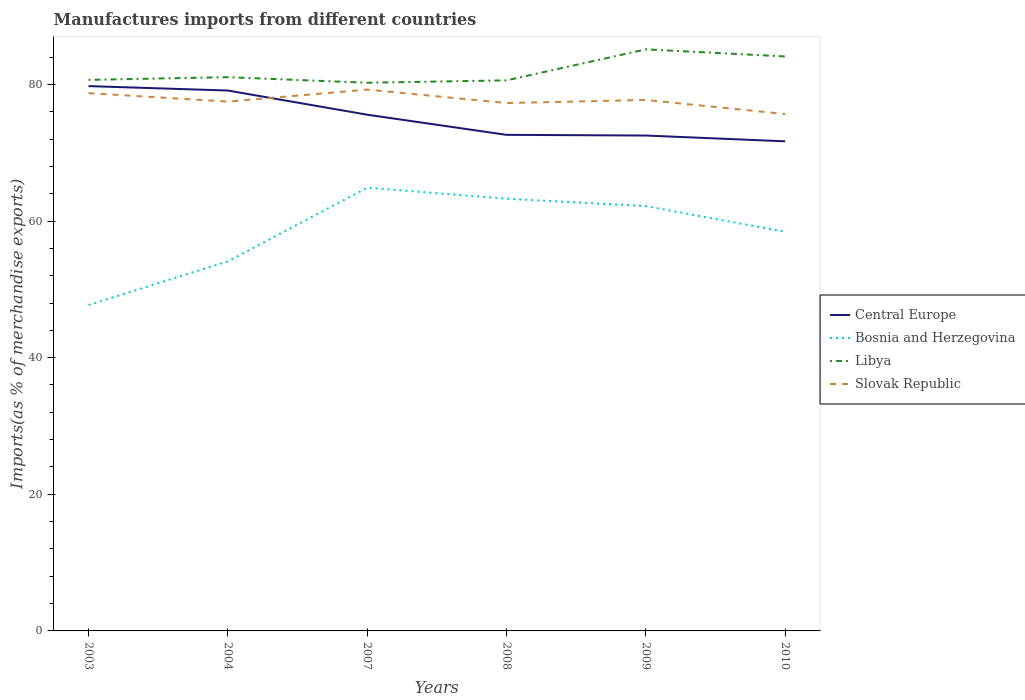How many different coloured lines are there?
Give a very brief answer. 4. Is the number of lines equal to the number of legend labels?
Offer a very short reply. Yes. Across all years, what is the maximum percentage of imports to different countries in Libya?
Your answer should be very brief. 80.24. What is the total percentage of imports to different countries in Central Europe in the graph?
Offer a very short reply. 8.08. What is the difference between the highest and the second highest percentage of imports to different countries in Libya?
Your answer should be compact. 4.89. What is the difference between the highest and the lowest percentage of imports to different countries in Central Europe?
Make the answer very short. 3. How many years are there in the graph?
Your response must be concise. 6. Does the graph contain grids?
Your answer should be compact. No. What is the title of the graph?
Keep it short and to the point. Manufactures imports from different countries. What is the label or title of the Y-axis?
Your answer should be compact. Imports(as % of merchandise exports). What is the Imports(as % of merchandise exports) in Central Europe in 2003?
Your answer should be compact. 79.75. What is the Imports(as % of merchandise exports) in Bosnia and Herzegovina in 2003?
Offer a very short reply. 47.71. What is the Imports(as % of merchandise exports) of Libya in 2003?
Your answer should be compact. 80.66. What is the Imports(as % of merchandise exports) in Slovak Republic in 2003?
Make the answer very short. 78.72. What is the Imports(as % of merchandise exports) in Central Europe in 2004?
Offer a terse response. 79.1. What is the Imports(as % of merchandise exports) of Bosnia and Herzegovina in 2004?
Your answer should be very brief. 54.1. What is the Imports(as % of merchandise exports) in Libya in 2004?
Keep it short and to the point. 81.06. What is the Imports(as % of merchandise exports) in Slovak Republic in 2004?
Your answer should be compact. 77.48. What is the Imports(as % of merchandise exports) of Central Europe in 2007?
Offer a terse response. 75.56. What is the Imports(as % of merchandise exports) of Bosnia and Herzegovina in 2007?
Your response must be concise. 64.88. What is the Imports(as % of merchandise exports) in Libya in 2007?
Make the answer very short. 80.24. What is the Imports(as % of merchandise exports) of Slovak Republic in 2007?
Provide a succinct answer. 79.24. What is the Imports(as % of merchandise exports) in Central Europe in 2008?
Provide a short and direct response. 72.62. What is the Imports(as % of merchandise exports) in Bosnia and Herzegovina in 2008?
Ensure brevity in your answer.  63.27. What is the Imports(as % of merchandise exports) of Libya in 2008?
Give a very brief answer. 80.59. What is the Imports(as % of merchandise exports) in Slovak Republic in 2008?
Provide a short and direct response. 77.27. What is the Imports(as % of merchandise exports) of Central Europe in 2009?
Provide a succinct answer. 72.52. What is the Imports(as % of merchandise exports) in Bosnia and Herzegovina in 2009?
Provide a succinct answer. 62.19. What is the Imports(as % of merchandise exports) in Libya in 2009?
Keep it short and to the point. 85.13. What is the Imports(as % of merchandise exports) of Slovak Republic in 2009?
Your answer should be very brief. 77.72. What is the Imports(as % of merchandise exports) in Central Europe in 2010?
Your answer should be very brief. 71.67. What is the Imports(as % of merchandise exports) of Bosnia and Herzegovina in 2010?
Offer a very short reply. 58.43. What is the Imports(as % of merchandise exports) of Libya in 2010?
Provide a short and direct response. 84.09. What is the Imports(as % of merchandise exports) of Slovak Republic in 2010?
Provide a short and direct response. 75.66. Across all years, what is the maximum Imports(as % of merchandise exports) of Central Europe?
Your response must be concise. 79.75. Across all years, what is the maximum Imports(as % of merchandise exports) of Bosnia and Herzegovina?
Your response must be concise. 64.88. Across all years, what is the maximum Imports(as % of merchandise exports) of Libya?
Provide a short and direct response. 85.13. Across all years, what is the maximum Imports(as % of merchandise exports) in Slovak Republic?
Give a very brief answer. 79.24. Across all years, what is the minimum Imports(as % of merchandise exports) of Central Europe?
Make the answer very short. 71.67. Across all years, what is the minimum Imports(as % of merchandise exports) of Bosnia and Herzegovina?
Keep it short and to the point. 47.71. Across all years, what is the minimum Imports(as % of merchandise exports) in Libya?
Give a very brief answer. 80.24. Across all years, what is the minimum Imports(as % of merchandise exports) of Slovak Republic?
Offer a very short reply. 75.66. What is the total Imports(as % of merchandise exports) in Central Europe in the graph?
Provide a succinct answer. 451.22. What is the total Imports(as % of merchandise exports) of Bosnia and Herzegovina in the graph?
Your response must be concise. 350.57. What is the total Imports(as % of merchandise exports) in Libya in the graph?
Your response must be concise. 491.78. What is the total Imports(as % of merchandise exports) in Slovak Republic in the graph?
Your answer should be very brief. 466.11. What is the difference between the Imports(as % of merchandise exports) of Central Europe in 2003 and that in 2004?
Give a very brief answer. 0.65. What is the difference between the Imports(as % of merchandise exports) of Bosnia and Herzegovina in 2003 and that in 2004?
Your answer should be very brief. -6.39. What is the difference between the Imports(as % of merchandise exports) of Libya in 2003 and that in 2004?
Provide a short and direct response. -0.4. What is the difference between the Imports(as % of merchandise exports) of Slovak Republic in 2003 and that in 2004?
Offer a very short reply. 1.24. What is the difference between the Imports(as % of merchandise exports) of Central Europe in 2003 and that in 2007?
Your answer should be very brief. 4.19. What is the difference between the Imports(as % of merchandise exports) in Bosnia and Herzegovina in 2003 and that in 2007?
Your response must be concise. -17.18. What is the difference between the Imports(as % of merchandise exports) in Libya in 2003 and that in 2007?
Make the answer very short. 0.42. What is the difference between the Imports(as % of merchandise exports) in Slovak Republic in 2003 and that in 2007?
Your answer should be compact. -0.52. What is the difference between the Imports(as % of merchandise exports) in Central Europe in 2003 and that in 2008?
Ensure brevity in your answer.  7.13. What is the difference between the Imports(as % of merchandise exports) of Bosnia and Herzegovina in 2003 and that in 2008?
Offer a terse response. -15.56. What is the difference between the Imports(as % of merchandise exports) in Libya in 2003 and that in 2008?
Your response must be concise. 0.07. What is the difference between the Imports(as % of merchandise exports) of Slovak Republic in 2003 and that in 2008?
Make the answer very short. 1.45. What is the difference between the Imports(as % of merchandise exports) of Central Europe in 2003 and that in 2009?
Your answer should be compact. 7.24. What is the difference between the Imports(as % of merchandise exports) in Bosnia and Herzegovina in 2003 and that in 2009?
Keep it short and to the point. -14.48. What is the difference between the Imports(as % of merchandise exports) of Libya in 2003 and that in 2009?
Provide a succinct answer. -4.47. What is the difference between the Imports(as % of merchandise exports) in Slovak Republic in 2003 and that in 2009?
Your answer should be very brief. 1. What is the difference between the Imports(as % of merchandise exports) of Central Europe in 2003 and that in 2010?
Provide a succinct answer. 8.08. What is the difference between the Imports(as % of merchandise exports) of Bosnia and Herzegovina in 2003 and that in 2010?
Your response must be concise. -10.72. What is the difference between the Imports(as % of merchandise exports) in Libya in 2003 and that in 2010?
Offer a very short reply. -3.43. What is the difference between the Imports(as % of merchandise exports) in Slovak Republic in 2003 and that in 2010?
Give a very brief answer. 3.06. What is the difference between the Imports(as % of merchandise exports) in Central Europe in 2004 and that in 2007?
Your response must be concise. 3.54. What is the difference between the Imports(as % of merchandise exports) in Bosnia and Herzegovina in 2004 and that in 2007?
Give a very brief answer. -10.78. What is the difference between the Imports(as % of merchandise exports) in Libya in 2004 and that in 2007?
Provide a succinct answer. 0.82. What is the difference between the Imports(as % of merchandise exports) of Slovak Republic in 2004 and that in 2007?
Your response must be concise. -1.76. What is the difference between the Imports(as % of merchandise exports) in Central Europe in 2004 and that in 2008?
Offer a terse response. 6.49. What is the difference between the Imports(as % of merchandise exports) in Bosnia and Herzegovina in 2004 and that in 2008?
Keep it short and to the point. -9.17. What is the difference between the Imports(as % of merchandise exports) of Libya in 2004 and that in 2008?
Offer a terse response. 0.47. What is the difference between the Imports(as % of merchandise exports) of Slovak Republic in 2004 and that in 2008?
Provide a short and direct response. 0.21. What is the difference between the Imports(as % of merchandise exports) of Central Europe in 2004 and that in 2009?
Offer a very short reply. 6.59. What is the difference between the Imports(as % of merchandise exports) of Bosnia and Herzegovina in 2004 and that in 2009?
Your answer should be very brief. -8.09. What is the difference between the Imports(as % of merchandise exports) in Libya in 2004 and that in 2009?
Your answer should be very brief. -4.07. What is the difference between the Imports(as % of merchandise exports) in Slovak Republic in 2004 and that in 2009?
Your answer should be compact. -0.24. What is the difference between the Imports(as % of merchandise exports) of Central Europe in 2004 and that in 2010?
Offer a very short reply. 7.44. What is the difference between the Imports(as % of merchandise exports) in Bosnia and Herzegovina in 2004 and that in 2010?
Offer a terse response. -4.33. What is the difference between the Imports(as % of merchandise exports) in Libya in 2004 and that in 2010?
Provide a succinct answer. -3.03. What is the difference between the Imports(as % of merchandise exports) in Slovak Republic in 2004 and that in 2010?
Offer a very short reply. 1.82. What is the difference between the Imports(as % of merchandise exports) in Central Europe in 2007 and that in 2008?
Offer a very short reply. 2.95. What is the difference between the Imports(as % of merchandise exports) of Bosnia and Herzegovina in 2007 and that in 2008?
Keep it short and to the point. 1.62. What is the difference between the Imports(as % of merchandise exports) in Libya in 2007 and that in 2008?
Give a very brief answer. -0.35. What is the difference between the Imports(as % of merchandise exports) of Slovak Republic in 2007 and that in 2008?
Your answer should be compact. 1.97. What is the difference between the Imports(as % of merchandise exports) in Central Europe in 2007 and that in 2009?
Your answer should be very brief. 3.05. What is the difference between the Imports(as % of merchandise exports) of Bosnia and Herzegovina in 2007 and that in 2009?
Make the answer very short. 2.7. What is the difference between the Imports(as % of merchandise exports) of Libya in 2007 and that in 2009?
Your answer should be compact. -4.89. What is the difference between the Imports(as % of merchandise exports) in Slovak Republic in 2007 and that in 2009?
Provide a succinct answer. 1.52. What is the difference between the Imports(as % of merchandise exports) in Central Europe in 2007 and that in 2010?
Keep it short and to the point. 3.9. What is the difference between the Imports(as % of merchandise exports) of Bosnia and Herzegovina in 2007 and that in 2010?
Ensure brevity in your answer.  6.46. What is the difference between the Imports(as % of merchandise exports) of Libya in 2007 and that in 2010?
Your answer should be very brief. -3.85. What is the difference between the Imports(as % of merchandise exports) in Slovak Republic in 2007 and that in 2010?
Provide a succinct answer. 3.58. What is the difference between the Imports(as % of merchandise exports) of Central Europe in 2008 and that in 2009?
Make the answer very short. 0.1. What is the difference between the Imports(as % of merchandise exports) of Bosnia and Herzegovina in 2008 and that in 2009?
Provide a succinct answer. 1.08. What is the difference between the Imports(as % of merchandise exports) of Libya in 2008 and that in 2009?
Keep it short and to the point. -4.54. What is the difference between the Imports(as % of merchandise exports) in Slovak Republic in 2008 and that in 2009?
Make the answer very short. -0.45. What is the difference between the Imports(as % of merchandise exports) of Central Europe in 2008 and that in 2010?
Provide a succinct answer. 0.95. What is the difference between the Imports(as % of merchandise exports) in Bosnia and Herzegovina in 2008 and that in 2010?
Your answer should be compact. 4.84. What is the difference between the Imports(as % of merchandise exports) in Libya in 2008 and that in 2010?
Your response must be concise. -3.5. What is the difference between the Imports(as % of merchandise exports) in Slovak Republic in 2008 and that in 2010?
Provide a succinct answer. 1.61. What is the difference between the Imports(as % of merchandise exports) of Central Europe in 2009 and that in 2010?
Provide a short and direct response. 0.85. What is the difference between the Imports(as % of merchandise exports) in Bosnia and Herzegovina in 2009 and that in 2010?
Your answer should be very brief. 3.76. What is the difference between the Imports(as % of merchandise exports) in Libya in 2009 and that in 2010?
Ensure brevity in your answer.  1.04. What is the difference between the Imports(as % of merchandise exports) of Slovak Republic in 2009 and that in 2010?
Your answer should be very brief. 2.06. What is the difference between the Imports(as % of merchandise exports) of Central Europe in 2003 and the Imports(as % of merchandise exports) of Bosnia and Herzegovina in 2004?
Your answer should be compact. 25.65. What is the difference between the Imports(as % of merchandise exports) of Central Europe in 2003 and the Imports(as % of merchandise exports) of Libya in 2004?
Offer a very short reply. -1.31. What is the difference between the Imports(as % of merchandise exports) in Central Europe in 2003 and the Imports(as % of merchandise exports) in Slovak Republic in 2004?
Make the answer very short. 2.27. What is the difference between the Imports(as % of merchandise exports) of Bosnia and Herzegovina in 2003 and the Imports(as % of merchandise exports) of Libya in 2004?
Your response must be concise. -33.35. What is the difference between the Imports(as % of merchandise exports) in Bosnia and Herzegovina in 2003 and the Imports(as % of merchandise exports) in Slovak Republic in 2004?
Offer a terse response. -29.78. What is the difference between the Imports(as % of merchandise exports) of Libya in 2003 and the Imports(as % of merchandise exports) of Slovak Republic in 2004?
Keep it short and to the point. 3.18. What is the difference between the Imports(as % of merchandise exports) in Central Europe in 2003 and the Imports(as % of merchandise exports) in Bosnia and Herzegovina in 2007?
Offer a terse response. 14.87. What is the difference between the Imports(as % of merchandise exports) of Central Europe in 2003 and the Imports(as % of merchandise exports) of Libya in 2007?
Ensure brevity in your answer.  -0.49. What is the difference between the Imports(as % of merchandise exports) of Central Europe in 2003 and the Imports(as % of merchandise exports) of Slovak Republic in 2007?
Provide a short and direct response. 0.51. What is the difference between the Imports(as % of merchandise exports) in Bosnia and Herzegovina in 2003 and the Imports(as % of merchandise exports) in Libya in 2007?
Give a very brief answer. -32.54. What is the difference between the Imports(as % of merchandise exports) of Bosnia and Herzegovina in 2003 and the Imports(as % of merchandise exports) of Slovak Republic in 2007?
Offer a very short reply. -31.53. What is the difference between the Imports(as % of merchandise exports) in Libya in 2003 and the Imports(as % of merchandise exports) in Slovak Republic in 2007?
Ensure brevity in your answer.  1.42. What is the difference between the Imports(as % of merchandise exports) of Central Europe in 2003 and the Imports(as % of merchandise exports) of Bosnia and Herzegovina in 2008?
Your answer should be very brief. 16.49. What is the difference between the Imports(as % of merchandise exports) in Central Europe in 2003 and the Imports(as % of merchandise exports) in Libya in 2008?
Offer a very short reply. -0.84. What is the difference between the Imports(as % of merchandise exports) of Central Europe in 2003 and the Imports(as % of merchandise exports) of Slovak Republic in 2008?
Your answer should be compact. 2.48. What is the difference between the Imports(as % of merchandise exports) of Bosnia and Herzegovina in 2003 and the Imports(as % of merchandise exports) of Libya in 2008?
Your response must be concise. -32.89. What is the difference between the Imports(as % of merchandise exports) in Bosnia and Herzegovina in 2003 and the Imports(as % of merchandise exports) in Slovak Republic in 2008?
Your answer should be very brief. -29.57. What is the difference between the Imports(as % of merchandise exports) of Libya in 2003 and the Imports(as % of merchandise exports) of Slovak Republic in 2008?
Your answer should be very brief. 3.39. What is the difference between the Imports(as % of merchandise exports) of Central Europe in 2003 and the Imports(as % of merchandise exports) of Bosnia and Herzegovina in 2009?
Your answer should be very brief. 17.57. What is the difference between the Imports(as % of merchandise exports) of Central Europe in 2003 and the Imports(as % of merchandise exports) of Libya in 2009?
Offer a terse response. -5.38. What is the difference between the Imports(as % of merchandise exports) in Central Europe in 2003 and the Imports(as % of merchandise exports) in Slovak Republic in 2009?
Offer a very short reply. 2.03. What is the difference between the Imports(as % of merchandise exports) of Bosnia and Herzegovina in 2003 and the Imports(as % of merchandise exports) of Libya in 2009?
Provide a succinct answer. -37.42. What is the difference between the Imports(as % of merchandise exports) of Bosnia and Herzegovina in 2003 and the Imports(as % of merchandise exports) of Slovak Republic in 2009?
Provide a succinct answer. -30.01. What is the difference between the Imports(as % of merchandise exports) of Libya in 2003 and the Imports(as % of merchandise exports) of Slovak Republic in 2009?
Your answer should be very brief. 2.94. What is the difference between the Imports(as % of merchandise exports) in Central Europe in 2003 and the Imports(as % of merchandise exports) in Bosnia and Herzegovina in 2010?
Offer a terse response. 21.33. What is the difference between the Imports(as % of merchandise exports) of Central Europe in 2003 and the Imports(as % of merchandise exports) of Libya in 2010?
Offer a very short reply. -4.34. What is the difference between the Imports(as % of merchandise exports) in Central Europe in 2003 and the Imports(as % of merchandise exports) in Slovak Republic in 2010?
Offer a very short reply. 4.09. What is the difference between the Imports(as % of merchandise exports) of Bosnia and Herzegovina in 2003 and the Imports(as % of merchandise exports) of Libya in 2010?
Keep it short and to the point. -36.39. What is the difference between the Imports(as % of merchandise exports) in Bosnia and Herzegovina in 2003 and the Imports(as % of merchandise exports) in Slovak Republic in 2010?
Provide a short and direct response. -27.96. What is the difference between the Imports(as % of merchandise exports) of Libya in 2003 and the Imports(as % of merchandise exports) of Slovak Republic in 2010?
Give a very brief answer. 5. What is the difference between the Imports(as % of merchandise exports) in Central Europe in 2004 and the Imports(as % of merchandise exports) in Bosnia and Herzegovina in 2007?
Provide a succinct answer. 14.22. What is the difference between the Imports(as % of merchandise exports) of Central Europe in 2004 and the Imports(as % of merchandise exports) of Libya in 2007?
Your response must be concise. -1.14. What is the difference between the Imports(as % of merchandise exports) of Central Europe in 2004 and the Imports(as % of merchandise exports) of Slovak Republic in 2007?
Your response must be concise. -0.14. What is the difference between the Imports(as % of merchandise exports) in Bosnia and Herzegovina in 2004 and the Imports(as % of merchandise exports) in Libya in 2007?
Your response must be concise. -26.15. What is the difference between the Imports(as % of merchandise exports) of Bosnia and Herzegovina in 2004 and the Imports(as % of merchandise exports) of Slovak Republic in 2007?
Provide a succinct answer. -25.14. What is the difference between the Imports(as % of merchandise exports) in Libya in 2004 and the Imports(as % of merchandise exports) in Slovak Republic in 2007?
Offer a terse response. 1.82. What is the difference between the Imports(as % of merchandise exports) of Central Europe in 2004 and the Imports(as % of merchandise exports) of Bosnia and Herzegovina in 2008?
Make the answer very short. 15.84. What is the difference between the Imports(as % of merchandise exports) in Central Europe in 2004 and the Imports(as % of merchandise exports) in Libya in 2008?
Your answer should be compact. -1.49. What is the difference between the Imports(as % of merchandise exports) of Central Europe in 2004 and the Imports(as % of merchandise exports) of Slovak Republic in 2008?
Offer a very short reply. 1.83. What is the difference between the Imports(as % of merchandise exports) of Bosnia and Herzegovina in 2004 and the Imports(as % of merchandise exports) of Libya in 2008?
Give a very brief answer. -26.5. What is the difference between the Imports(as % of merchandise exports) of Bosnia and Herzegovina in 2004 and the Imports(as % of merchandise exports) of Slovak Republic in 2008?
Offer a terse response. -23.17. What is the difference between the Imports(as % of merchandise exports) in Libya in 2004 and the Imports(as % of merchandise exports) in Slovak Republic in 2008?
Provide a succinct answer. 3.79. What is the difference between the Imports(as % of merchandise exports) of Central Europe in 2004 and the Imports(as % of merchandise exports) of Bosnia and Herzegovina in 2009?
Provide a succinct answer. 16.92. What is the difference between the Imports(as % of merchandise exports) in Central Europe in 2004 and the Imports(as % of merchandise exports) in Libya in 2009?
Provide a succinct answer. -6.03. What is the difference between the Imports(as % of merchandise exports) in Central Europe in 2004 and the Imports(as % of merchandise exports) in Slovak Republic in 2009?
Offer a very short reply. 1.38. What is the difference between the Imports(as % of merchandise exports) in Bosnia and Herzegovina in 2004 and the Imports(as % of merchandise exports) in Libya in 2009?
Give a very brief answer. -31.03. What is the difference between the Imports(as % of merchandise exports) of Bosnia and Herzegovina in 2004 and the Imports(as % of merchandise exports) of Slovak Republic in 2009?
Your answer should be compact. -23.62. What is the difference between the Imports(as % of merchandise exports) in Libya in 2004 and the Imports(as % of merchandise exports) in Slovak Republic in 2009?
Your answer should be compact. 3.34. What is the difference between the Imports(as % of merchandise exports) in Central Europe in 2004 and the Imports(as % of merchandise exports) in Bosnia and Herzegovina in 2010?
Ensure brevity in your answer.  20.68. What is the difference between the Imports(as % of merchandise exports) of Central Europe in 2004 and the Imports(as % of merchandise exports) of Libya in 2010?
Offer a terse response. -4.99. What is the difference between the Imports(as % of merchandise exports) of Central Europe in 2004 and the Imports(as % of merchandise exports) of Slovak Republic in 2010?
Make the answer very short. 3.44. What is the difference between the Imports(as % of merchandise exports) in Bosnia and Herzegovina in 2004 and the Imports(as % of merchandise exports) in Libya in 2010?
Give a very brief answer. -30. What is the difference between the Imports(as % of merchandise exports) of Bosnia and Herzegovina in 2004 and the Imports(as % of merchandise exports) of Slovak Republic in 2010?
Your answer should be compact. -21.57. What is the difference between the Imports(as % of merchandise exports) in Libya in 2004 and the Imports(as % of merchandise exports) in Slovak Republic in 2010?
Ensure brevity in your answer.  5.39. What is the difference between the Imports(as % of merchandise exports) in Central Europe in 2007 and the Imports(as % of merchandise exports) in Bosnia and Herzegovina in 2008?
Offer a very short reply. 12.3. What is the difference between the Imports(as % of merchandise exports) of Central Europe in 2007 and the Imports(as % of merchandise exports) of Libya in 2008?
Provide a short and direct response. -5.03. What is the difference between the Imports(as % of merchandise exports) of Central Europe in 2007 and the Imports(as % of merchandise exports) of Slovak Republic in 2008?
Give a very brief answer. -1.71. What is the difference between the Imports(as % of merchandise exports) in Bosnia and Herzegovina in 2007 and the Imports(as % of merchandise exports) in Libya in 2008?
Your response must be concise. -15.71. What is the difference between the Imports(as % of merchandise exports) in Bosnia and Herzegovina in 2007 and the Imports(as % of merchandise exports) in Slovak Republic in 2008?
Your answer should be compact. -12.39. What is the difference between the Imports(as % of merchandise exports) of Libya in 2007 and the Imports(as % of merchandise exports) of Slovak Republic in 2008?
Your answer should be compact. 2.97. What is the difference between the Imports(as % of merchandise exports) of Central Europe in 2007 and the Imports(as % of merchandise exports) of Bosnia and Herzegovina in 2009?
Your answer should be compact. 13.38. What is the difference between the Imports(as % of merchandise exports) in Central Europe in 2007 and the Imports(as % of merchandise exports) in Libya in 2009?
Keep it short and to the point. -9.57. What is the difference between the Imports(as % of merchandise exports) of Central Europe in 2007 and the Imports(as % of merchandise exports) of Slovak Republic in 2009?
Keep it short and to the point. -2.16. What is the difference between the Imports(as % of merchandise exports) in Bosnia and Herzegovina in 2007 and the Imports(as % of merchandise exports) in Libya in 2009?
Offer a terse response. -20.25. What is the difference between the Imports(as % of merchandise exports) in Bosnia and Herzegovina in 2007 and the Imports(as % of merchandise exports) in Slovak Republic in 2009?
Your response must be concise. -12.84. What is the difference between the Imports(as % of merchandise exports) in Libya in 2007 and the Imports(as % of merchandise exports) in Slovak Republic in 2009?
Ensure brevity in your answer.  2.52. What is the difference between the Imports(as % of merchandise exports) in Central Europe in 2007 and the Imports(as % of merchandise exports) in Bosnia and Herzegovina in 2010?
Offer a terse response. 17.14. What is the difference between the Imports(as % of merchandise exports) of Central Europe in 2007 and the Imports(as % of merchandise exports) of Libya in 2010?
Ensure brevity in your answer.  -8.53. What is the difference between the Imports(as % of merchandise exports) in Central Europe in 2007 and the Imports(as % of merchandise exports) in Slovak Republic in 2010?
Offer a very short reply. -0.1. What is the difference between the Imports(as % of merchandise exports) of Bosnia and Herzegovina in 2007 and the Imports(as % of merchandise exports) of Libya in 2010?
Your response must be concise. -19.21. What is the difference between the Imports(as % of merchandise exports) in Bosnia and Herzegovina in 2007 and the Imports(as % of merchandise exports) in Slovak Republic in 2010?
Your answer should be compact. -10.78. What is the difference between the Imports(as % of merchandise exports) of Libya in 2007 and the Imports(as % of merchandise exports) of Slovak Republic in 2010?
Provide a succinct answer. 4.58. What is the difference between the Imports(as % of merchandise exports) in Central Europe in 2008 and the Imports(as % of merchandise exports) in Bosnia and Herzegovina in 2009?
Offer a very short reply. 10.43. What is the difference between the Imports(as % of merchandise exports) of Central Europe in 2008 and the Imports(as % of merchandise exports) of Libya in 2009?
Your answer should be compact. -12.51. What is the difference between the Imports(as % of merchandise exports) in Central Europe in 2008 and the Imports(as % of merchandise exports) in Slovak Republic in 2009?
Your answer should be compact. -5.1. What is the difference between the Imports(as % of merchandise exports) of Bosnia and Herzegovina in 2008 and the Imports(as % of merchandise exports) of Libya in 2009?
Your answer should be compact. -21.86. What is the difference between the Imports(as % of merchandise exports) of Bosnia and Herzegovina in 2008 and the Imports(as % of merchandise exports) of Slovak Republic in 2009?
Your response must be concise. -14.46. What is the difference between the Imports(as % of merchandise exports) of Libya in 2008 and the Imports(as % of merchandise exports) of Slovak Republic in 2009?
Offer a very short reply. 2.87. What is the difference between the Imports(as % of merchandise exports) of Central Europe in 2008 and the Imports(as % of merchandise exports) of Bosnia and Herzegovina in 2010?
Your answer should be very brief. 14.19. What is the difference between the Imports(as % of merchandise exports) of Central Europe in 2008 and the Imports(as % of merchandise exports) of Libya in 2010?
Provide a succinct answer. -11.48. What is the difference between the Imports(as % of merchandise exports) in Central Europe in 2008 and the Imports(as % of merchandise exports) in Slovak Republic in 2010?
Keep it short and to the point. -3.05. What is the difference between the Imports(as % of merchandise exports) of Bosnia and Herzegovina in 2008 and the Imports(as % of merchandise exports) of Libya in 2010?
Offer a terse response. -20.83. What is the difference between the Imports(as % of merchandise exports) of Bosnia and Herzegovina in 2008 and the Imports(as % of merchandise exports) of Slovak Republic in 2010?
Give a very brief answer. -12.4. What is the difference between the Imports(as % of merchandise exports) in Libya in 2008 and the Imports(as % of merchandise exports) in Slovak Republic in 2010?
Ensure brevity in your answer.  4.93. What is the difference between the Imports(as % of merchandise exports) of Central Europe in 2009 and the Imports(as % of merchandise exports) of Bosnia and Herzegovina in 2010?
Offer a very short reply. 14.09. What is the difference between the Imports(as % of merchandise exports) in Central Europe in 2009 and the Imports(as % of merchandise exports) in Libya in 2010?
Your answer should be very brief. -11.58. What is the difference between the Imports(as % of merchandise exports) of Central Europe in 2009 and the Imports(as % of merchandise exports) of Slovak Republic in 2010?
Your response must be concise. -3.15. What is the difference between the Imports(as % of merchandise exports) of Bosnia and Herzegovina in 2009 and the Imports(as % of merchandise exports) of Libya in 2010?
Provide a short and direct response. -21.91. What is the difference between the Imports(as % of merchandise exports) of Bosnia and Herzegovina in 2009 and the Imports(as % of merchandise exports) of Slovak Republic in 2010?
Your response must be concise. -13.48. What is the difference between the Imports(as % of merchandise exports) in Libya in 2009 and the Imports(as % of merchandise exports) in Slovak Republic in 2010?
Your answer should be very brief. 9.47. What is the average Imports(as % of merchandise exports) in Central Europe per year?
Provide a succinct answer. 75.2. What is the average Imports(as % of merchandise exports) in Bosnia and Herzegovina per year?
Give a very brief answer. 58.43. What is the average Imports(as % of merchandise exports) of Libya per year?
Your answer should be very brief. 81.96. What is the average Imports(as % of merchandise exports) of Slovak Republic per year?
Your answer should be compact. 77.68. In the year 2003, what is the difference between the Imports(as % of merchandise exports) of Central Europe and Imports(as % of merchandise exports) of Bosnia and Herzegovina?
Your answer should be very brief. 32.04. In the year 2003, what is the difference between the Imports(as % of merchandise exports) of Central Europe and Imports(as % of merchandise exports) of Libya?
Offer a terse response. -0.91. In the year 2003, what is the difference between the Imports(as % of merchandise exports) in Central Europe and Imports(as % of merchandise exports) in Slovak Republic?
Make the answer very short. 1.03. In the year 2003, what is the difference between the Imports(as % of merchandise exports) of Bosnia and Herzegovina and Imports(as % of merchandise exports) of Libya?
Ensure brevity in your answer.  -32.95. In the year 2003, what is the difference between the Imports(as % of merchandise exports) in Bosnia and Herzegovina and Imports(as % of merchandise exports) in Slovak Republic?
Give a very brief answer. -31.01. In the year 2003, what is the difference between the Imports(as % of merchandise exports) of Libya and Imports(as % of merchandise exports) of Slovak Republic?
Ensure brevity in your answer.  1.94. In the year 2004, what is the difference between the Imports(as % of merchandise exports) in Central Europe and Imports(as % of merchandise exports) in Bosnia and Herzegovina?
Offer a terse response. 25.01. In the year 2004, what is the difference between the Imports(as % of merchandise exports) of Central Europe and Imports(as % of merchandise exports) of Libya?
Give a very brief answer. -1.95. In the year 2004, what is the difference between the Imports(as % of merchandise exports) of Central Europe and Imports(as % of merchandise exports) of Slovak Republic?
Your answer should be very brief. 1.62. In the year 2004, what is the difference between the Imports(as % of merchandise exports) of Bosnia and Herzegovina and Imports(as % of merchandise exports) of Libya?
Ensure brevity in your answer.  -26.96. In the year 2004, what is the difference between the Imports(as % of merchandise exports) of Bosnia and Herzegovina and Imports(as % of merchandise exports) of Slovak Republic?
Ensure brevity in your answer.  -23.39. In the year 2004, what is the difference between the Imports(as % of merchandise exports) in Libya and Imports(as % of merchandise exports) in Slovak Republic?
Your answer should be very brief. 3.57. In the year 2007, what is the difference between the Imports(as % of merchandise exports) in Central Europe and Imports(as % of merchandise exports) in Bosnia and Herzegovina?
Your answer should be compact. 10.68. In the year 2007, what is the difference between the Imports(as % of merchandise exports) of Central Europe and Imports(as % of merchandise exports) of Libya?
Offer a terse response. -4.68. In the year 2007, what is the difference between the Imports(as % of merchandise exports) in Central Europe and Imports(as % of merchandise exports) in Slovak Republic?
Offer a terse response. -3.68. In the year 2007, what is the difference between the Imports(as % of merchandise exports) in Bosnia and Herzegovina and Imports(as % of merchandise exports) in Libya?
Offer a terse response. -15.36. In the year 2007, what is the difference between the Imports(as % of merchandise exports) of Bosnia and Herzegovina and Imports(as % of merchandise exports) of Slovak Republic?
Keep it short and to the point. -14.36. In the year 2007, what is the difference between the Imports(as % of merchandise exports) of Libya and Imports(as % of merchandise exports) of Slovak Republic?
Provide a short and direct response. 1. In the year 2008, what is the difference between the Imports(as % of merchandise exports) in Central Europe and Imports(as % of merchandise exports) in Bosnia and Herzegovina?
Make the answer very short. 9.35. In the year 2008, what is the difference between the Imports(as % of merchandise exports) of Central Europe and Imports(as % of merchandise exports) of Libya?
Make the answer very short. -7.98. In the year 2008, what is the difference between the Imports(as % of merchandise exports) in Central Europe and Imports(as % of merchandise exports) in Slovak Republic?
Keep it short and to the point. -4.66. In the year 2008, what is the difference between the Imports(as % of merchandise exports) of Bosnia and Herzegovina and Imports(as % of merchandise exports) of Libya?
Offer a very short reply. -17.33. In the year 2008, what is the difference between the Imports(as % of merchandise exports) in Bosnia and Herzegovina and Imports(as % of merchandise exports) in Slovak Republic?
Your response must be concise. -14.01. In the year 2008, what is the difference between the Imports(as % of merchandise exports) of Libya and Imports(as % of merchandise exports) of Slovak Republic?
Provide a short and direct response. 3.32. In the year 2009, what is the difference between the Imports(as % of merchandise exports) of Central Europe and Imports(as % of merchandise exports) of Bosnia and Herzegovina?
Offer a terse response. 10.33. In the year 2009, what is the difference between the Imports(as % of merchandise exports) in Central Europe and Imports(as % of merchandise exports) in Libya?
Provide a succinct answer. -12.61. In the year 2009, what is the difference between the Imports(as % of merchandise exports) in Central Europe and Imports(as % of merchandise exports) in Slovak Republic?
Keep it short and to the point. -5.2. In the year 2009, what is the difference between the Imports(as % of merchandise exports) of Bosnia and Herzegovina and Imports(as % of merchandise exports) of Libya?
Offer a very short reply. -22.95. In the year 2009, what is the difference between the Imports(as % of merchandise exports) of Bosnia and Herzegovina and Imports(as % of merchandise exports) of Slovak Republic?
Provide a succinct answer. -15.54. In the year 2009, what is the difference between the Imports(as % of merchandise exports) in Libya and Imports(as % of merchandise exports) in Slovak Republic?
Offer a very short reply. 7.41. In the year 2010, what is the difference between the Imports(as % of merchandise exports) of Central Europe and Imports(as % of merchandise exports) of Bosnia and Herzegovina?
Provide a short and direct response. 13.24. In the year 2010, what is the difference between the Imports(as % of merchandise exports) of Central Europe and Imports(as % of merchandise exports) of Libya?
Your response must be concise. -12.43. In the year 2010, what is the difference between the Imports(as % of merchandise exports) in Central Europe and Imports(as % of merchandise exports) in Slovak Republic?
Provide a short and direct response. -4. In the year 2010, what is the difference between the Imports(as % of merchandise exports) of Bosnia and Herzegovina and Imports(as % of merchandise exports) of Libya?
Your answer should be compact. -25.67. In the year 2010, what is the difference between the Imports(as % of merchandise exports) of Bosnia and Herzegovina and Imports(as % of merchandise exports) of Slovak Republic?
Make the answer very short. -17.24. In the year 2010, what is the difference between the Imports(as % of merchandise exports) in Libya and Imports(as % of merchandise exports) in Slovak Republic?
Provide a succinct answer. 8.43. What is the ratio of the Imports(as % of merchandise exports) of Central Europe in 2003 to that in 2004?
Offer a terse response. 1.01. What is the ratio of the Imports(as % of merchandise exports) of Bosnia and Herzegovina in 2003 to that in 2004?
Your response must be concise. 0.88. What is the ratio of the Imports(as % of merchandise exports) of Slovak Republic in 2003 to that in 2004?
Your answer should be very brief. 1.02. What is the ratio of the Imports(as % of merchandise exports) of Central Europe in 2003 to that in 2007?
Provide a short and direct response. 1.06. What is the ratio of the Imports(as % of merchandise exports) in Bosnia and Herzegovina in 2003 to that in 2007?
Provide a short and direct response. 0.74. What is the ratio of the Imports(as % of merchandise exports) of Slovak Republic in 2003 to that in 2007?
Provide a short and direct response. 0.99. What is the ratio of the Imports(as % of merchandise exports) of Central Europe in 2003 to that in 2008?
Your response must be concise. 1.1. What is the ratio of the Imports(as % of merchandise exports) in Bosnia and Herzegovina in 2003 to that in 2008?
Keep it short and to the point. 0.75. What is the ratio of the Imports(as % of merchandise exports) of Slovak Republic in 2003 to that in 2008?
Give a very brief answer. 1.02. What is the ratio of the Imports(as % of merchandise exports) in Central Europe in 2003 to that in 2009?
Keep it short and to the point. 1.1. What is the ratio of the Imports(as % of merchandise exports) of Bosnia and Herzegovina in 2003 to that in 2009?
Your response must be concise. 0.77. What is the ratio of the Imports(as % of merchandise exports) of Libya in 2003 to that in 2009?
Offer a terse response. 0.95. What is the ratio of the Imports(as % of merchandise exports) in Slovak Republic in 2003 to that in 2009?
Give a very brief answer. 1.01. What is the ratio of the Imports(as % of merchandise exports) in Central Europe in 2003 to that in 2010?
Your answer should be very brief. 1.11. What is the ratio of the Imports(as % of merchandise exports) in Bosnia and Herzegovina in 2003 to that in 2010?
Provide a short and direct response. 0.82. What is the ratio of the Imports(as % of merchandise exports) of Libya in 2003 to that in 2010?
Keep it short and to the point. 0.96. What is the ratio of the Imports(as % of merchandise exports) in Slovak Republic in 2003 to that in 2010?
Your response must be concise. 1.04. What is the ratio of the Imports(as % of merchandise exports) in Central Europe in 2004 to that in 2007?
Give a very brief answer. 1.05. What is the ratio of the Imports(as % of merchandise exports) of Bosnia and Herzegovina in 2004 to that in 2007?
Your answer should be compact. 0.83. What is the ratio of the Imports(as % of merchandise exports) in Libya in 2004 to that in 2007?
Your answer should be very brief. 1.01. What is the ratio of the Imports(as % of merchandise exports) of Slovak Republic in 2004 to that in 2007?
Provide a short and direct response. 0.98. What is the ratio of the Imports(as % of merchandise exports) of Central Europe in 2004 to that in 2008?
Provide a short and direct response. 1.09. What is the ratio of the Imports(as % of merchandise exports) in Bosnia and Herzegovina in 2004 to that in 2008?
Provide a short and direct response. 0.86. What is the ratio of the Imports(as % of merchandise exports) in Slovak Republic in 2004 to that in 2008?
Give a very brief answer. 1. What is the ratio of the Imports(as % of merchandise exports) in Central Europe in 2004 to that in 2009?
Provide a succinct answer. 1.09. What is the ratio of the Imports(as % of merchandise exports) in Bosnia and Herzegovina in 2004 to that in 2009?
Provide a succinct answer. 0.87. What is the ratio of the Imports(as % of merchandise exports) in Libya in 2004 to that in 2009?
Ensure brevity in your answer.  0.95. What is the ratio of the Imports(as % of merchandise exports) in Slovak Republic in 2004 to that in 2009?
Your response must be concise. 1. What is the ratio of the Imports(as % of merchandise exports) of Central Europe in 2004 to that in 2010?
Offer a very short reply. 1.1. What is the ratio of the Imports(as % of merchandise exports) of Bosnia and Herzegovina in 2004 to that in 2010?
Your response must be concise. 0.93. What is the ratio of the Imports(as % of merchandise exports) in Libya in 2004 to that in 2010?
Offer a very short reply. 0.96. What is the ratio of the Imports(as % of merchandise exports) of Slovak Republic in 2004 to that in 2010?
Provide a succinct answer. 1.02. What is the ratio of the Imports(as % of merchandise exports) in Central Europe in 2007 to that in 2008?
Give a very brief answer. 1.04. What is the ratio of the Imports(as % of merchandise exports) in Bosnia and Herzegovina in 2007 to that in 2008?
Your answer should be compact. 1.03. What is the ratio of the Imports(as % of merchandise exports) of Libya in 2007 to that in 2008?
Your answer should be very brief. 1. What is the ratio of the Imports(as % of merchandise exports) in Slovak Republic in 2007 to that in 2008?
Make the answer very short. 1.03. What is the ratio of the Imports(as % of merchandise exports) of Central Europe in 2007 to that in 2009?
Make the answer very short. 1.04. What is the ratio of the Imports(as % of merchandise exports) in Bosnia and Herzegovina in 2007 to that in 2009?
Ensure brevity in your answer.  1.04. What is the ratio of the Imports(as % of merchandise exports) in Libya in 2007 to that in 2009?
Give a very brief answer. 0.94. What is the ratio of the Imports(as % of merchandise exports) of Slovak Republic in 2007 to that in 2009?
Your response must be concise. 1.02. What is the ratio of the Imports(as % of merchandise exports) of Central Europe in 2007 to that in 2010?
Provide a short and direct response. 1.05. What is the ratio of the Imports(as % of merchandise exports) of Bosnia and Herzegovina in 2007 to that in 2010?
Give a very brief answer. 1.11. What is the ratio of the Imports(as % of merchandise exports) of Libya in 2007 to that in 2010?
Provide a succinct answer. 0.95. What is the ratio of the Imports(as % of merchandise exports) in Slovak Republic in 2007 to that in 2010?
Offer a very short reply. 1.05. What is the ratio of the Imports(as % of merchandise exports) of Bosnia and Herzegovina in 2008 to that in 2009?
Make the answer very short. 1.02. What is the ratio of the Imports(as % of merchandise exports) in Libya in 2008 to that in 2009?
Make the answer very short. 0.95. What is the ratio of the Imports(as % of merchandise exports) in Slovak Republic in 2008 to that in 2009?
Offer a very short reply. 0.99. What is the ratio of the Imports(as % of merchandise exports) of Central Europe in 2008 to that in 2010?
Provide a succinct answer. 1.01. What is the ratio of the Imports(as % of merchandise exports) of Bosnia and Herzegovina in 2008 to that in 2010?
Your response must be concise. 1.08. What is the ratio of the Imports(as % of merchandise exports) of Libya in 2008 to that in 2010?
Provide a succinct answer. 0.96. What is the ratio of the Imports(as % of merchandise exports) of Slovak Republic in 2008 to that in 2010?
Your response must be concise. 1.02. What is the ratio of the Imports(as % of merchandise exports) of Central Europe in 2009 to that in 2010?
Your response must be concise. 1.01. What is the ratio of the Imports(as % of merchandise exports) of Bosnia and Herzegovina in 2009 to that in 2010?
Provide a succinct answer. 1.06. What is the ratio of the Imports(as % of merchandise exports) of Libya in 2009 to that in 2010?
Make the answer very short. 1.01. What is the ratio of the Imports(as % of merchandise exports) in Slovak Republic in 2009 to that in 2010?
Give a very brief answer. 1.03. What is the difference between the highest and the second highest Imports(as % of merchandise exports) of Central Europe?
Provide a succinct answer. 0.65. What is the difference between the highest and the second highest Imports(as % of merchandise exports) in Bosnia and Herzegovina?
Offer a terse response. 1.62. What is the difference between the highest and the second highest Imports(as % of merchandise exports) in Libya?
Your response must be concise. 1.04. What is the difference between the highest and the second highest Imports(as % of merchandise exports) in Slovak Republic?
Your answer should be compact. 0.52. What is the difference between the highest and the lowest Imports(as % of merchandise exports) in Central Europe?
Your answer should be compact. 8.08. What is the difference between the highest and the lowest Imports(as % of merchandise exports) of Bosnia and Herzegovina?
Keep it short and to the point. 17.18. What is the difference between the highest and the lowest Imports(as % of merchandise exports) of Libya?
Offer a very short reply. 4.89. What is the difference between the highest and the lowest Imports(as % of merchandise exports) of Slovak Republic?
Offer a very short reply. 3.58. 